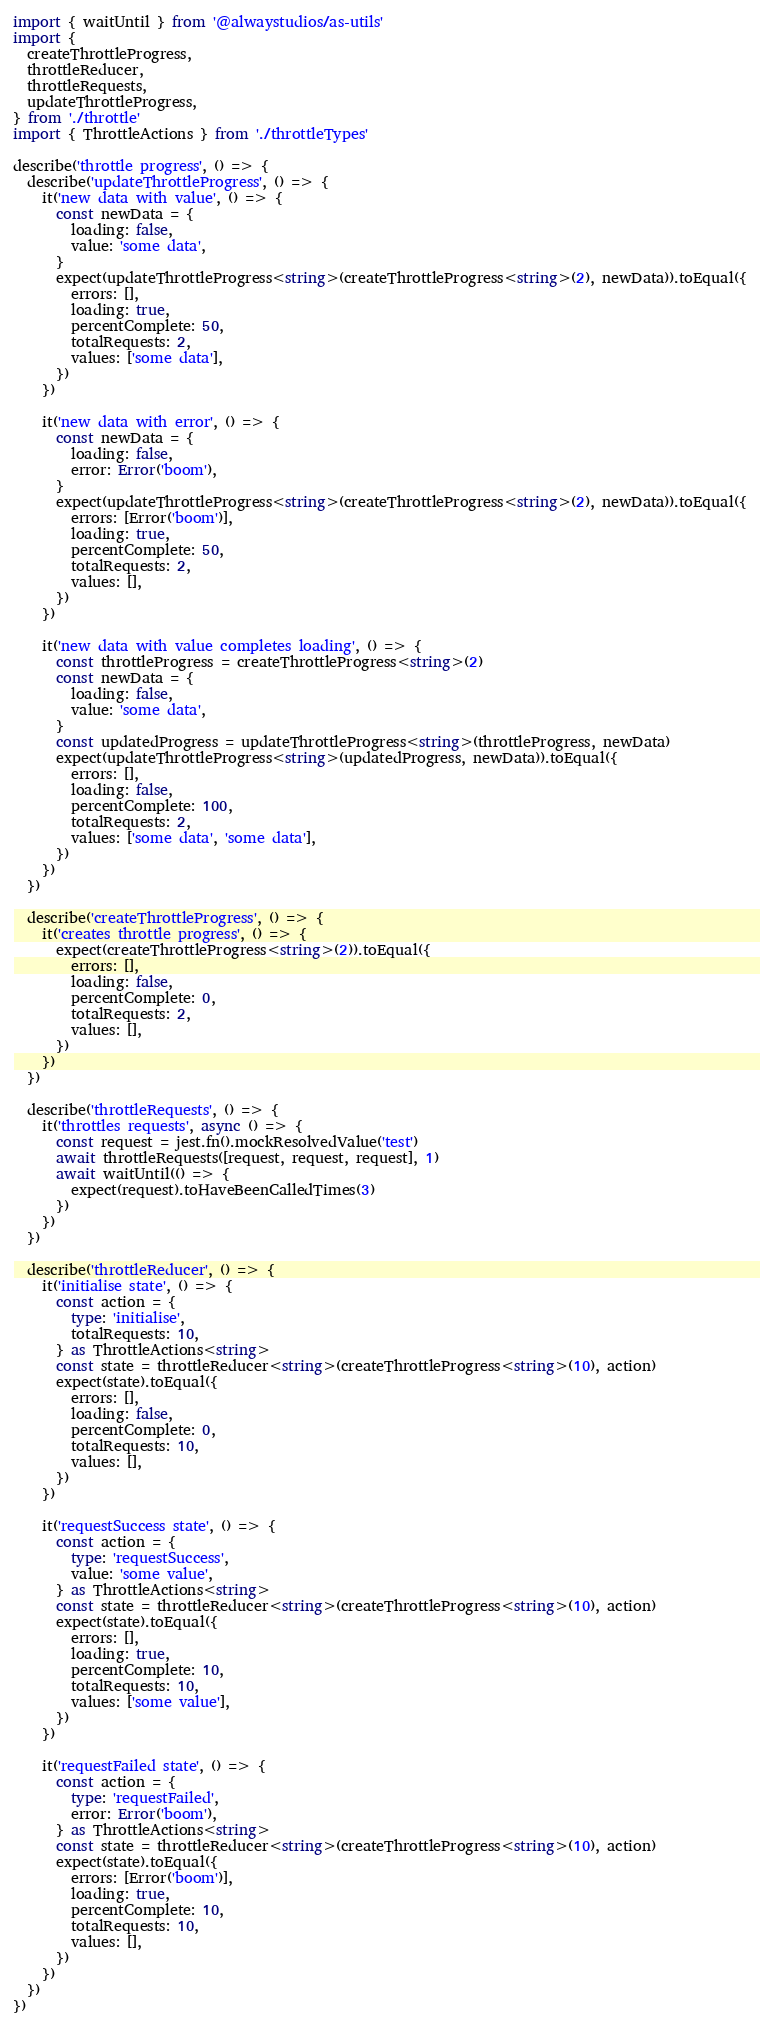<code> <loc_0><loc_0><loc_500><loc_500><_TypeScript_>import { waitUntil } from '@alwaystudios/as-utils'
import {
  createThrottleProgress,
  throttleReducer,
  throttleRequests,
  updateThrottleProgress,
} from './throttle'
import { ThrottleActions } from './throttleTypes'

describe('throttle progress', () => {
  describe('updateThrottleProgress', () => {
    it('new data with value', () => {
      const newData = {
        loading: false,
        value: 'some data',
      }
      expect(updateThrottleProgress<string>(createThrottleProgress<string>(2), newData)).toEqual({
        errors: [],
        loading: true,
        percentComplete: 50,
        totalRequests: 2,
        values: ['some data'],
      })
    })

    it('new data with error', () => {
      const newData = {
        loading: false,
        error: Error('boom'),
      }
      expect(updateThrottleProgress<string>(createThrottleProgress<string>(2), newData)).toEqual({
        errors: [Error('boom')],
        loading: true,
        percentComplete: 50,
        totalRequests: 2,
        values: [],
      })
    })

    it('new data with value completes loading', () => {
      const throttleProgress = createThrottleProgress<string>(2)
      const newData = {
        loading: false,
        value: 'some data',
      }
      const updatedProgress = updateThrottleProgress<string>(throttleProgress, newData)
      expect(updateThrottleProgress<string>(updatedProgress, newData)).toEqual({
        errors: [],
        loading: false,
        percentComplete: 100,
        totalRequests: 2,
        values: ['some data', 'some data'],
      })
    })
  })

  describe('createThrottleProgress', () => {
    it('creates throttle progress', () => {
      expect(createThrottleProgress<string>(2)).toEqual({
        errors: [],
        loading: false,
        percentComplete: 0,
        totalRequests: 2,
        values: [],
      })
    })
  })

  describe('throttleRequests', () => {
    it('throttles requests', async () => {
      const request = jest.fn().mockResolvedValue('test')
      await throttleRequests([request, request, request], 1)
      await waitUntil(() => {
        expect(request).toHaveBeenCalledTimes(3)
      })
    })
  })

  describe('throttleReducer', () => {
    it('initialise state', () => {
      const action = {
        type: 'initialise',
        totalRequests: 10,
      } as ThrottleActions<string>
      const state = throttleReducer<string>(createThrottleProgress<string>(10), action)
      expect(state).toEqual({
        errors: [],
        loading: false,
        percentComplete: 0,
        totalRequests: 10,
        values: [],
      })
    })

    it('requestSuccess state', () => {
      const action = {
        type: 'requestSuccess',
        value: 'some value',
      } as ThrottleActions<string>
      const state = throttleReducer<string>(createThrottleProgress<string>(10), action)
      expect(state).toEqual({
        errors: [],
        loading: true,
        percentComplete: 10,
        totalRequests: 10,
        values: ['some value'],
      })
    })

    it('requestFailed state', () => {
      const action = {
        type: 'requestFailed',
        error: Error('boom'),
      } as ThrottleActions<string>
      const state = throttleReducer<string>(createThrottleProgress<string>(10), action)
      expect(state).toEqual({
        errors: [Error('boom')],
        loading: true,
        percentComplete: 10,
        totalRequests: 10,
        values: [],
      })
    })
  })
})
</code> 